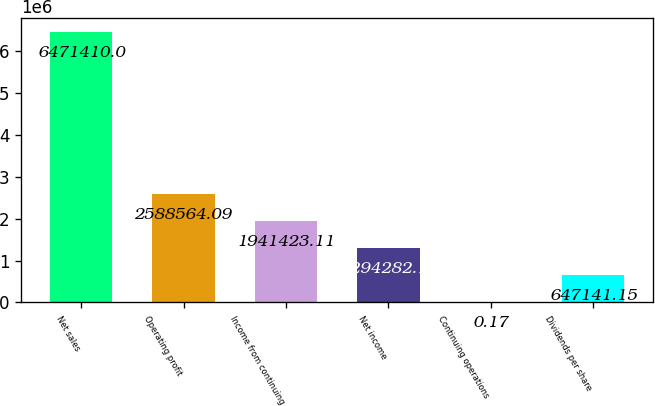Convert chart. <chart><loc_0><loc_0><loc_500><loc_500><bar_chart><fcel>Net sales<fcel>Operating profit<fcel>Income from continuing<fcel>Net income<fcel>Continuing operations<fcel>Dividends per share<nl><fcel>6.47141e+06<fcel>2.58856e+06<fcel>1.94142e+06<fcel>1.29428e+06<fcel>0.17<fcel>647141<nl></chart> 